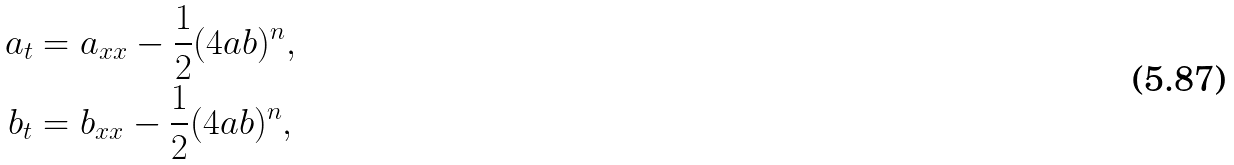<formula> <loc_0><loc_0><loc_500><loc_500>a _ { t } & = a _ { x x } - \frac { 1 } { 2 } ( 4 a b ) ^ { n } , \\ b _ { t } & = b _ { x x } - \frac { 1 } { 2 } ( 4 a b ) ^ { n } ,</formula> 